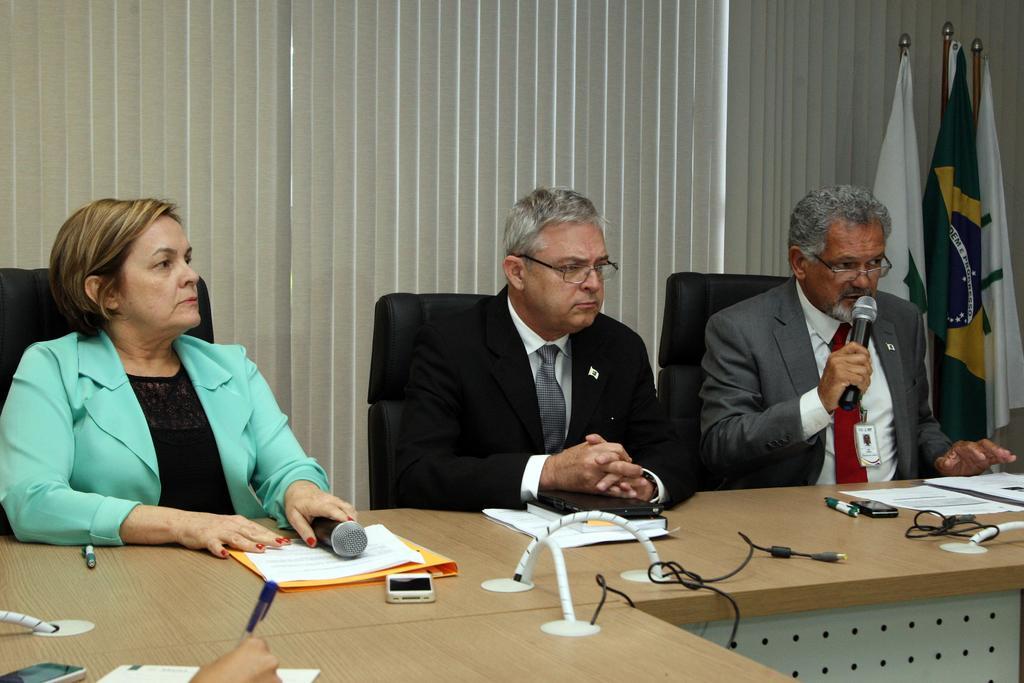Can you describe this image briefly? In this image I can see three persons are sitting on the chairs in front of a table on which papers, books, mobiles, wires, some objects are kept and two persons are holding mics in their hand. In the background I can see flag poles and curtains. This image is taken may be in a hall. 